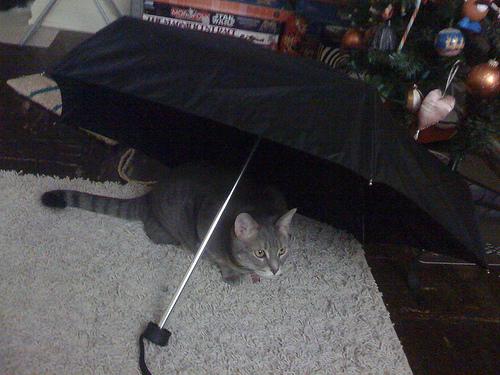Is the cat holding the umbrella?
Write a very short answer. No. Is it raining?
Write a very short answer. No. What is the likelihood the cat knows what humans actually use the umbrella for?
Answer briefly. 0. 